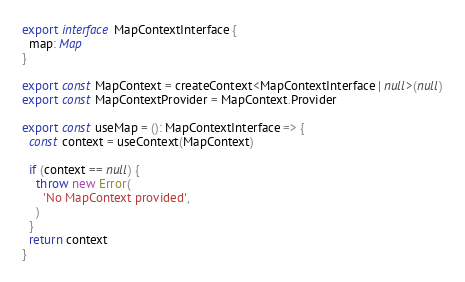<code> <loc_0><loc_0><loc_500><loc_500><_TypeScript_>export interface MapContextInterface {
  map: Map
}

export const MapContext = createContext<MapContextInterface | null>(null)
export const MapContextProvider = MapContext.Provider

export const useMap = (): MapContextInterface => {
  const context = useContext(MapContext)

  if (context == null) {
    throw new Error(
      'No MapContext provided',
    )
  }
  return context
}
</code> 